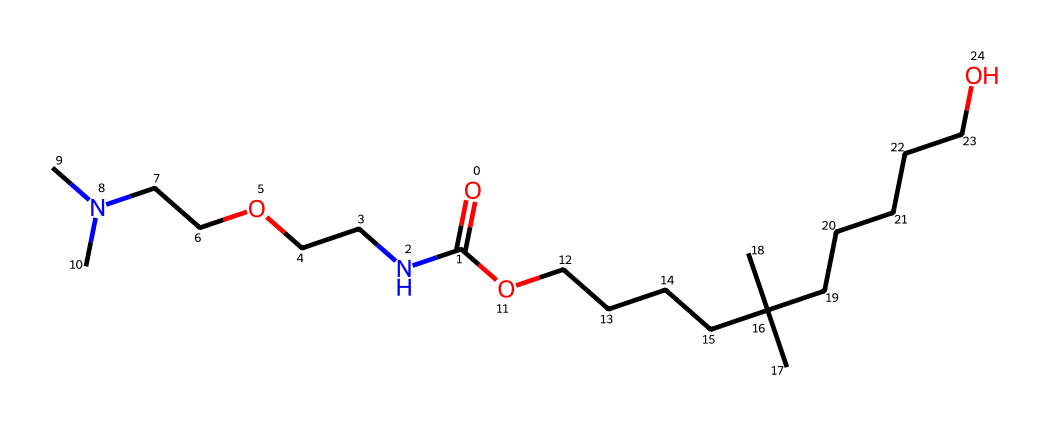how many carbon atoms are in the molecule? To determine the number of carbon atoms, we look at the structure represented by the SMILES. Each "C" in the SMILES indicates a carbon atom, and we count them. The provided SMILES contains 15 "C" symbols.
Answer: 15 what is the functional group present in this chemical? By scanning the SMILES, we can identify the presence of the carbonyl group (C=O) at the beginning of the structure and the amine group (N attached to carbons) as functional groups. This indicates that the chemical can be classified as a type of amide due to the carbonyl connected to a nitrogen atom.
Answer: amide how many nitrogen atoms are in the molecule? In the provided SMILES, we identify nitrogen atoms represented by "N." There are a total of 3 "N" notations in the structure, which indicates that there are 3 nitrogen atoms present.
Answer: 3 what type of polymer is formed from this molecular structure? The given molecular structure suggests it forms a polyurethane polymer due to the presence of isocyanate-functionalized groups in its structure (which will combine with alcohols like the ether linkages seen here). Polyurethanes are known for their flexibility and use in cushioning materials, such as in dog beds.
Answer: polyurethane is this molecule likely to be hydrophilic or hydrophobic? We evaluate the structure based on the presence of functional groups. The molecule contains several polar groups such as amide and ether linkages which are typically hydrophilic. Thus, one can infer that this molecule would be generally hydrophilic.
Answer: hydrophilic what is the likely application of this polymer? The polymer's flexibility, durability, and cushioning properties, along with its hydrophilic nature, suggest its application as cushioning material in products like dog beds and toys. These attributes are desirable in these contexts to provide comfort for pets.
Answer: dog beds and toys 